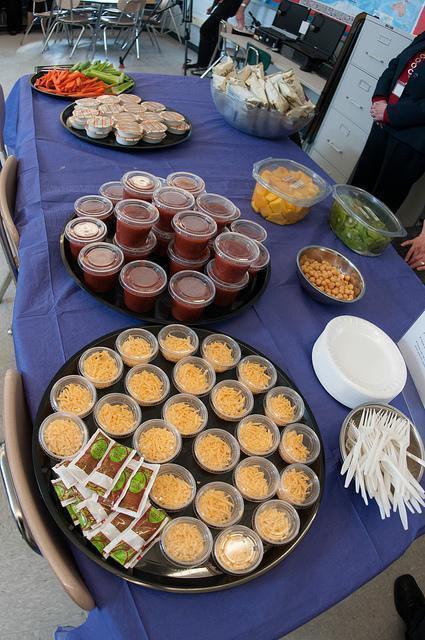How many dining tables are there?
Give a very brief answer. 1. How many bowls are visible?
Give a very brief answer. 5. 